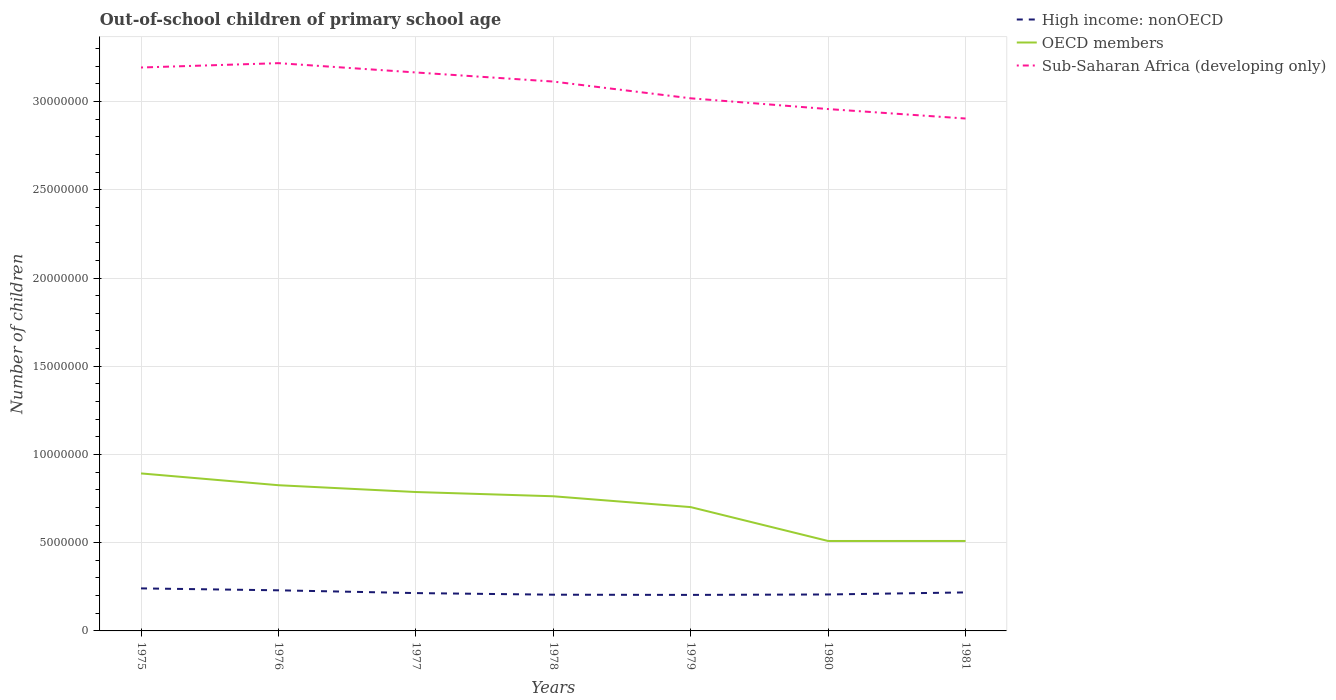Does the line corresponding to Sub-Saharan Africa (developing only) intersect with the line corresponding to OECD members?
Offer a terse response. No. Is the number of lines equal to the number of legend labels?
Your response must be concise. Yes. Across all years, what is the maximum number of out-of-school children in OECD members?
Ensure brevity in your answer.  5.10e+06. What is the total number of out-of-school children in High income: nonOECD in the graph?
Provide a short and direct response. 2.28e+05. What is the difference between the highest and the second highest number of out-of-school children in Sub-Saharan Africa (developing only)?
Keep it short and to the point. 3.14e+06. What is the difference between the highest and the lowest number of out-of-school children in Sub-Saharan Africa (developing only)?
Make the answer very short. 4. How many lines are there?
Your response must be concise. 3. How many years are there in the graph?
Give a very brief answer. 7. Are the values on the major ticks of Y-axis written in scientific E-notation?
Ensure brevity in your answer.  No. Does the graph contain any zero values?
Offer a very short reply. No. Where does the legend appear in the graph?
Ensure brevity in your answer.  Top right. How many legend labels are there?
Ensure brevity in your answer.  3. How are the legend labels stacked?
Your answer should be compact. Vertical. What is the title of the graph?
Ensure brevity in your answer.  Out-of-school children of primary school age. Does "Grenada" appear as one of the legend labels in the graph?
Your answer should be very brief. No. What is the label or title of the Y-axis?
Ensure brevity in your answer.  Number of children. What is the Number of children in High income: nonOECD in 1975?
Provide a short and direct response. 2.41e+06. What is the Number of children of OECD members in 1975?
Offer a very short reply. 8.93e+06. What is the Number of children of Sub-Saharan Africa (developing only) in 1975?
Give a very brief answer. 3.19e+07. What is the Number of children of High income: nonOECD in 1976?
Offer a very short reply. 2.30e+06. What is the Number of children in OECD members in 1976?
Offer a very short reply. 8.26e+06. What is the Number of children of Sub-Saharan Africa (developing only) in 1976?
Ensure brevity in your answer.  3.22e+07. What is the Number of children of High income: nonOECD in 1977?
Your answer should be very brief. 2.14e+06. What is the Number of children of OECD members in 1977?
Make the answer very short. 7.87e+06. What is the Number of children in Sub-Saharan Africa (developing only) in 1977?
Give a very brief answer. 3.17e+07. What is the Number of children in High income: nonOECD in 1978?
Offer a very short reply. 2.05e+06. What is the Number of children in OECD members in 1978?
Ensure brevity in your answer.  7.63e+06. What is the Number of children of Sub-Saharan Africa (developing only) in 1978?
Make the answer very short. 3.11e+07. What is the Number of children in High income: nonOECD in 1979?
Give a very brief answer. 2.04e+06. What is the Number of children of OECD members in 1979?
Offer a terse response. 7.02e+06. What is the Number of children of Sub-Saharan Africa (developing only) in 1979?
Your answer should be compact. 3.02e+07. What is the Number of children in High income: nonOECD in 1980?
Provide a short and direct response. 2.07e+06. What is the Number of children of OECD members in 1980?
Ensure brevity in your answer.  5.10e+06. What is the Number of children in Sub-Saharan Africa (developing only) in 1980?
Offer a terse response. 2.96e+07. What is the Number of children in High income: nonOECD in 1981?
Offer a terse response. 2.18e+06. What is the Number of children of OECD members in 1981?
Provide a short and direct response. 5.10e+06. What is the Number of children in Sub-Saharan Africa (developing only) in 1981?
Your answer should be very brief. 2.90e+07. Across all years, what is the maximum Number of children in High income: nonOECD?
Offer a very short reply. 2.41e+06. Across all years, what is the maximum Number of children in OECD members?
Provide a short and direct response. 8.93e+06. Across all years, what is the maximum Number of children in Sub-Saharan Africa (developing only)?
Your answer should be very brief. 3.22e+07. Across all years, what is the minimum Number of children of High income: nonOECD?
Your answer should be very brief. 2.04e+06. Across all years, what is the minimum Number of children in OECD members?
Give a very brief answer. 5.10e+06. Across all years, what is the minimum Number of children in Sub-Saharan Africa (developing only)?
Keep it short and to the point. 2.90e+07. What is the total Number of children in High income: nonOECD in the graph?
Keep it short and to the point. 1.52e+07. What is the total Number of children of OECD members in the graph?
Your answer should be compact. 4.99e+07. What is the total Number of children in Sub-Saharan Africa (developing only) in the graph?
Provide a short and direct response. 2.16e+08. What is the difference between the Number of children of High income: nonOECD in 1975 and that in 1976?
Provide a short and direct response. 1.09e+05. What is the difference between the Number of children of OECD members in 1975 and that in 1976?
Your answer should be compact. 6.68e+05. What is the difference between the Number of children in Sub-Saharan Africa (developing only) in 1975 and that in 1976?
Provide a succinct answer. -2.46e+05. What is the difference between the Number of children in High income: nonOECD in 1975 and that in 1977?
Offer a very short reply. 2.66e+05. What is the difference between the Number of children of OECD members in 1975 and that in 1977?
Keep it short and to the point. 1.05e+06. What is the difference between the Number of children of Sub-Saharan Africa (developing only) in 1975 and that in 1977?
Your answer should be very brief. 2.81e+05. What is the difference between the Number of children in High income: nonOECD in 1975 and that in 1978?
Your response must be concise. 3.58e+05. What is the difference between the Number of children of OECD members in 1975 and that in 1978?
Ensure brevity in your answer.  1.29e+06. What is the difference between the Number of children of Sub-Saharan Africa (developing only) in 1975 and that in 1978?
Provide a succinct answer. 7.97e+05. What is the difference between the Number of children of High income: nonOECD in 1975 and that in 1979?
Provide a succinct answer. 3.69e+05. What is the difference between the Number of children in OECD members in 1975 and that in 1979?
Provide a short and direct response. 1.91e+06. What is the difference between the Number of children of Sub-Saharan Africa (developing only) in 1975 and that in 1979?
Offer a terse response. 1.75e+06. What is the difference between the Number of children of High income: nonOECD in 1975 and that in 1980?
Make the answer very short. 3.45e+05. What is the difference between the Number of children of OECD members in 1975 and that in 1980?
Make the answer very short. 3.83e+06. What is the difference between the Number of children of Sub-Saharan Africa (developing only) in 1975 and that in 1980?
Ensure brevity in your answer.  2.36e+06. What is the difference between the Number of children in High income: nonOECD in 1975 and that in 1981?
Give a very brief answer. 2.28e+05. What is the difference between the Number of children of OECD members in 1975 and that in 1981?
Offer a very short reply. 3.83e+06. What is the difference between the Number of children in Sub-Saharan Africa (developing only) in 1975 and that in 1981?
Your answer should be very brief. 2.89e+06. What is the difference between the Number of children of High income: nonOECD in 1976 and that in 1977?
Ensure brevity in your answer.  1.57e+05. What is the difference between the Number of children of OECD members in 1976 and that in 1977?
Keep it short and to the point. 3.86e+05. What is the difference between the Number of children of Sub-Saharan Africa (developing only) in 1976 and that in 1977?
Ensure brevity in your answer.  5.27e+05. What is the difference between the Number of children of High income: nonOECD in 1976 and that in 1978?
Your response must be concise. 2.49e+05. What is the difference between the Number of children of OECD members in 1976 and that in 1978?
Keep it short and to the point. 6.26e+05. What is the difference between the Number of children of Sub-Saharan Africa (developing only) in 1976 and that in 1978?
Provide a succinct answer. 1.04e+06. What is the difference between the Number of children in High income: nonOECD in 1976 and that in 1979?
Make the answer very short. 2.61e+05. What is the difference between the Number of children of OECD members in 1976 and that in 1979?
Keep it short and to the point. 1.24e+06. What is the difference between the Number of children in Sub-Saharan Africa (developing only) in 1976 and that in 1979?
Offer a very short reply. 1.99e+06. What is the difference between the Number of children of High income: nonOECD in 1976 and that in 1980?
Keep it short and to the point. 2.36e+05. What is the difference between the Number of children of OECD members in 1976 and that in 1980?
Your response must be concise. 3.16e+06. What is the difference between the Number of children in Sub-Saharan Africa (developing only) in 1976 and that in 1980?
Make the answer very short. 2.60e+06. What is the difference between the Number of children in High income: nonOECD in 1976 and that in 1981?
Ensure brevity in your answer.  1.19e+05. What is the difference between the Number of children in OECD members in 1976 and that in 1981?
Keep it short and to the point. 3.16e+06. What is the difference between the Number of children of Sub-Saharan Africa (developing only) in 1976 and that in 1981?
Give a very brief answer. 3.14e+06. What is the difference between the Number of children of High income: nonOECD in 1977 and that in 1978?
Your response must be concise. 9.15e+04. What is the difference between the Number of children in OECD members in 1977 and that in 1978?
Your response must be concise. 2.41e+05. What is the difference between the Number of children in Sub-Saharan Africa (developing only) in 1977 and that in 1978?
Your response must be concise. 5.15e+05. What is the difference between the Number of children of High income: nonOECD in 1977 and that in 1979?
Give a very brief answer. 1.03e+05. What is the difference between the Number of children of OECD members in 1977 and that in 1979?
Ensure brevity in your answer.  8.55e+05. What is the difference between the Number of children in Sub-Saharan Africa (developing only) in 1977 and that in 1979?
Provide a succinct answer. 1.46e+06. What is the difference between the Number of children of High income: nonOECD in 1977 and that in 1980?
Your response must be concise. 7.85e+04. What is the difference between the Number of children of OECD members in 1977 and that in 1980?
Offer a terse response. 2.78e+06. What is the difference between the Number of children in Sub-Saharan Africa (developing only) in 1977 and that in 1980?
Make the answer very short. 2.07e+06. What is the difference between the Number of children in High income: nonOECD in 1977 and that in 1981?
Your answer should be compact. -3.80e+04. What is the difference between the Number of children in OECD members in 1977 and that in 1981?
Offer a very short reply. 2.77e+06. What is the difference between the Number of children in Sub-Saharan Africa (developing only) in 1977 and that in 1981?
Provide a succinct answer. 2.61e+06. What is the difference between the Number of children in High income: nonOECD in 1978 and that in 1979?
Ensure brevity in your answer.  1.17e+04. What is the difference between the Number of children in OECD members in 1978 and that in 1979?
Ensure brevity in your answer.  6.15e+05. What is the difference between the Number of children in Sub-Saharan Africa (developing only) in 1978 and that in 1979?
Ensure brevity in your answer.  9.50e+05. What is the difference between the Number of children of High income: nonOECD in 1978 and that in 1980?
Provide a succinct answer. -1.30e+04. What is the difference between the Number of children in OECD members in 1978 and that in 1980?
Your response must be concise. 2.53e+06. What is the difference between the Number of children in Sub-Saharan Africa (developing only) in 1978 and that in 1980?
Keep it short and to the point. 1.56e+06. What is the difference between the Number of children of High income: nonOECD in 1978 and that in 1981?
Keep it short and to the point. -1.30e+05. What is the difference between the Number of children in OECD members in 1978 and that in 1981?
Offer a terse response. 2.53e+06. What is the difference between the Number of children in Sub-Saharan Africa (developing only) in 1978 and that in 1981?
Your answer should be compact. 2.10e+06. What is the difference between the Number of children of High income: nonOECD in 1979 and that in 1980?
Your answer should be compact. -2.47e+04. What is the difference between the Number of children of OECD members in 1979 and that in 1980?
Make the answer very short. 1.92e+06. What is the difference between the Number of children of Sub-Saharan Africa (developing only) in 1979 and that in 1980?
Provide a succinct answer. 6.09e+05. What is the difference between the Number of children in High income: nonOECD in 1979 and that in 1981?
Offer a very short reply. -1.41e+05. What is the difference between the Number of children of OECD members in 1979 and that in 1981?
Your response must be concise. 1.92e+06. What is the difference between the Number of children in Sub-Saharan Africa (developing only) in 1979 and that in 1981?
Offer a terse response. 1.15e+06. What is the difference between the Number of children in High income: nonOECD in 1980 and that in 1981?
Ensure brevity in your answer.  -1.17e+05. What is the difference between the Number of children of OECD members in 1980 and that in 1981?
Offer a very short reply. -943. What is the difference between the Number of children of Sub-Saharan Africa (developing only) in 1980 and that in 1981?
Ensure brevity in your answer.  5.36e+05. What is the difference between the Number of children of High income: nonOECD in 1975 and the Number of children of OECD members in 1976?
Keep it short and to the point. -5.85e+06. What is the difference between the Number of children in High income: nonOECD in 1975 and the Number of children in Sub-Saharan Africa (developing only) in 1976?
Give a very brief answer. -2.98e+07. What is the difference between the Number of children in OECD members in 1975 and the Number of children in Sub-Saharan Africa (developing only) in 1976?
Your answer should be very brief. -2.33e+07. What is the difference between the Number of children in High income: nonOECD in 1975 and the Number of children in OECD members in 1977?
Your answer should be very brief. -5.46e+06. What is the difference between the Number of children of High income: nonOECD in 1975 and the Number of children of Sub-Saharan Africa (developing only) in 1977?
Provide a short and direct response. -2.92e+07. What is the difference between the Number of children of OECD members in 1975 and the Number of children of Sub-Saharan Africa (developing only) in 1977?
Offer a terse response. -2.27e+07. What is the difference between the Number of children in High income: nonOECD in 1975 and the Number of children in OECD members in 1978?
Provide a succinct answer. -5.22e+06. What is the difference between the Number of children in High income: nonOECD in 1975 and the Number of children in Sub-Saharan Africa (developing only) in 1978?
Offer a very short reply. -2.87e+07. What is the difference between the Number of children of OECD members in 1975 and the Number of children of Sub-Saharan Africa (developing only) in 1978?
Make the answer very short. -2.22e+07. What is the difference between the Number of children of High income: nonOECD in 1975 and the Number of children of OECD members in 1979?
Your answer should be very brief. -4.61e+06. What is the difference between the Number of children of High income: nonOECD in 1975 and the Number of children of Sub-Saharan Africa (developing only) in 1979?
Your response must be concise. -2.78e+07. What is the difference between the Number of children in OECD members in 1975 and the Number of children in Sub-Saharan Africa (developing only) in 1979?
Make the answer very short. -2.13e+07. What is the difference between the Number of children in High income: nonOECD in 1975 and the Number of children in OECD members in 1980?
Keep it short and to the point. -2.69e+06. What is the difference between the Number of children in High income: nonOECD in 1975 and the Number of children in Sub-Saharan Africa (developing only) in 1980?
Ensure brevity in your answer.  -2.72e+07. What is the difference between the Number of children of OECD members in 1975 and the Number of children of Sub-Saharan Africa (developing only) in 1980?
Offer a very short reply. -2.07e+07. What is the difference between the Number of children in High income: nonOECD in 1975 and the Number of children in OECD members in 1981?
Offer a very short reply. -2.69e+06. What is the difference between the Number of children in High income: nonOECD in 1975 and the Number of children in Sub-Saharan Africa (developing only) in 1981?
Offer a very short reply. -2.66e+07. What is the difference between the Number of children in OECD members in 1975 and the Number of children in Sub-Saharan Africa (developing only) in 1981?
Ensure brevity in your answer.  -2.01e+07. What is the difference between the Number of children of High income: nonOECD in 1976 and the Number of children of OECD members in 1977?
Keep it short and to the point. -5.57e+06. What is the difference between the Number of children of High income: nonOECD in 1976 and the Number of children of Sub-Saharan Africa (developing only) in 1977?
Ensure brevity in your answer.  -2.93e+07. What is the difference between the Number of children in OECD members in 1976 and the Number of children in Sub-Saharan Africa (developing only) in 1977?
Your response must be concise. -2.34e+07. What is the difference between the Number of children of High income: nonOECD in 1976 and the Number of children of OECD members in 1978?
Your answer should be very brief. -5.33e+06. What is the difference between the Number of children of High income: nonOECD in 1976 and the Number of children of Sub-Saharan Africa (developing only) in 1978?
Ensure brevity in your answer.  -2.88e+07. What is the difference between the Number of children in OECD members in 1976 and the Number of children in Sub-Saharan Africa (developing only) in 1978?
Offer a very short reply. -2.29e+07. What is the difference between the Number of children in High income: nonOECD in 1976 and the Number of children in OECD members in 1979?
Your answer should be very brief. -4.72e+06. What is the difference between the Number of children of High income: nonOECD in 1976 and the Number of children of Sub-Saharan Africa (developing only) in 1979?
Your response must be concise. -2.79e+07. What is the difference between the Number of children in OECD members in 1976 and the Number of children in Sub-Saharan Africa (developing only) in 1979?
Offer a very short reply. -2.19e+07. What is the difference between the Number of children of High income: nonOECD in 1976 and the Number of children of OECD members in 1980?
Your answer should be very brief. -2.79e+06. What is the difference between the Number of children in High income: nonOECD in 1976 and the Number of children in Sub-Saharan Africa (developing only) in 1980?
Give a very brief answer. -2.73e+07. What is the difference between the Number of children in OECD members in 1976 and the Number of children in Sub-Saharan Africa (developing only) in 1980?
Provide a succinct answer. -2.13e+07. What is the difference between the Number of children of High income: nonOECD in 1976 and the Number of children of OECD members in 1981?
Provide a succinct answer. -2.80e+06. What is the difference between the Number of children in High income: nonOECD in 1976 and the Number of children in Sub-Saharan Africa (developing only) in 1981?
Offer a very short reply. -2.67e+07. What is the difference between the Number of children in OECD members in 1976 and the Number of children in Sub-Saharan Africa (developing only) in 1981?
Offer a terse response. -2.08e+07. What is the difference between the Number of children of High income: nonOECD in 1977 and the Number of children of OECD members in 1978?
Offer a very short reply. -5.49e+06. What is the difference between the Number of children of High income: nonOECD in 1977 and the Number of children of Sub-Saharan Africa (developing only) in 1978?
Offer a very short reply. -2.90e+07. What is the difference between the Number of children of OECD members in 1977 and the Number of children of Sub-Saharan Africa (developing only) in 1978?
Provide a succinct answer. -2.33e+07. What is the difference between the Number of children in High income: nonOECD in 1977 and the Number of children in OECD members in 1979?
Ensure brevity in your answer.  -4.87e+06. What is the difference between the Number of children in High income: nonOECD in 1977 and the Number of children in Sub-Saharan Africa (developing only) in 1979?
Offer a very short reply. -2.80e+07. What is the difference between the Number of children in OECD members in 1977 and the Number of children in Sub-Saharan Africa (developing only) in 1979?
Your response must be concise. -2.23e+07. What is the difference between the Number of children of High income: nonOECD in 1977 and the Number of children of OECD members in 1980?
Your answer should be very brief. -2.95e+06. What is the difference between the Number of children of High income: nonOECD in 1977 and the Number of children of Sub-Saharan Africa (developing only) in 1980?
Your response must be concise. -2.74e+07. What is the difference between the Number of children of OECD members in 1977 and the Number of children of Sub-Saharan Africa (developing only) in 1980?
Keep it short and to the point. -2.17e+07. What is the difference between the Number of children in High income: nonOECD in 1977 and the Number of children in OECD members in 1981?
Make the answer very short. -2.95e+06. What is the difference between the Number of children of High income: nonOECD in 1977 and the Number of children of Sub-Saharan Africa (developing only) in 1981?
Your answer should be very brief. -2.69e+07. What is the difference between the Number of children in OECD members in 1977 and the Number of children in Sub-Saharan Africa (developing only) in 1981?
Give a very brief answer. -2.12e+07. What is the difference between the Number of children in High income: nonOECD in 1978 and the Number of children in OECD members in 1979?
Ensure brevity in your answer.  -4.96e+06. What is the difference between the Number of children of High income: nonOECD in 1978 and the Number of children of Sub-Saharan Africa (developing only) in 1979?
Your response must be concise. -2.81e+07. What is the difference between the Number of children of OECD members in 1978 and the Number of children of Sub-Saharan Africa (developing only) in 1979?
Your answer should be compact. -2.26e+07. What is the difference between the Number of children of High income: nonOECD in 1978 and the Number of children of OECD members in 1980?
Ensure brevity in your answer.  -3.04e+06. What is the difference between the Number of children of High income: nonOECD in 1978 and the Number of children of Sub-Saharan Africa (developing only) in 1980?
Your answer should be compact. -2.75e+07. What is the difference between the Number of children in OECD members in 1978 and the Number of children in Sub-Saharan Africa (developing only) in 1980?
Provide a short and direct response. -2.19e+07. What is the difference between the Number of children in High income: nonOECD in 1978 and the Number of children in OECD members in 1981?
Offer a very short reply. -3.04e+06. What is the difference between the Number of children of High income: nonOECD in 1978 and the Number of children of Sub-Saharan Africa (developing only) in 1981?
Your answer should be very brief. -2.70e+07. What is the difference between the Number of children in OECD members in 1978 and the Number of children in Sub-Saharan Africa (developing only) in 1981?
Provide a succinct answer. -2.14e+07. What is the difference between the Number of children of High income: nonOECD in 1979 and the Number of children of OECD members in 1980?
Your answer should be very brief. -3.06e+06. What is the difference between the Number of children of High income: nonOECD in 1979 and the Number of children of Sub-Saharan Africa (developing only) in 1980?
Your answer should be very brief. -2.75e+07. What is the difference between the Number of children of OECD members in 1979 and the Number of children of Sub-Saharan Africa (developing only) in 1980?
Give a very brief answer. -2.26e+07. What is the difference between the Number of children in High income: nonOECD in 1979 and the Number of children in OECD members in 1981?
Provide a short and direct response. -3.06e+06. What is the difference between the Number of children in High income: nonOECD in 1979 and the Number of children in Sub-Saharan Africa (developing only) in 1981?
Ensure brevity in your answer.  -2.70e+07. What is the difference between the Number of children in OECD members in 1979 and the Number of children in Sub-Saharan Africa (developing only) in 1981?
Give a very brief answer. -2.20e+07. What is the difference between the Number of children in High income: nonOECD in 1980 and the Number of children in OECD members in 1981?
Ensure brevity in your answer.  -3.03e+06. What is the difference between the Number of children in High income: nonOECD in 1980 and the Number of children in Sub-Saharan Africa (developing only) in 1981?
Offer a very short reply. -2.70e+07. What is the difference between the Number of children of OECD members in 1980 and the Number of children of Sub-Saharan Africa (developing only) in 1981?
Give a very brief answer. -2.39e+07. What is the average Number of children of High income: nonOECD per year?
Your answer should be very brief. 2.17e+06. What is the average Number of children of OECD members per year?
Your answer should be compact. 7.13e+06. What is the average Number of children in Sub-Saharan Africa (developing only) per year?
Keep it short and to the point. 3.08e+07. In the year 1975, what is the difference between the Number of children in High income: nonOECD and Number of children in OECD members?
Keep it short and to the point. -6.52e+06. In the year 1975, what is the difference between the Number of children in High income: nonOECD and Number of children in Sub-Saharan Africa (developing only)?
Offer a very short reply. -2.95e+07. In the year 1975, what is the difference between the Number of children in OECD members and Number of children in Sub-Saharan Africa (developing only)?
Keep it short and to the point. -2.30e+07. In the year 1976, what is the difference between the Number of children of High income: nonOECD and Number of children of OECD members?
Give a very brief answer. -5.96e+06. In the year 1976, what is the difference between the Number of children in High income: nonOECD and Number of children in Sub-Saharan Africa (developing only)?
Provide a succinct answer. -2.99e+07. In the year 1976, what is the difference between the Number of children of OECD members and Number of children of Sub-Saharan Africa (developing only)?
Give a very brief answer. -2.39e+07. In the year 1977, what is the difference between the Number of children of High income: nonOECD and Number of children of OECD members?
Give a very brief answer. -5.73e+06. In the year 1977, what is the difference between the Number of children in High income: nonOECD and Number of children in Sub-Saharan Africa (developing only)?
Ensure brevity in your answer.  -2.95e+07. In the year 1977, what is the difference between the Number of children in OECD members and Number of children in Sub-Saharan Africa (developing only)?
Provide a short and direct response. -2.38e+07. In the year 1978, what is the difference between the Number of children of High income: nonOECD and Number of children of OECD members?
Make the answer very short. -5.58e+06. In the year 1978, what is the difference between the Number of children in High income: nonOECD and Number of children in Sub-Saharan Africa (developing only)?
Keep it short and to the point. -2.91e+07. In the year 1978, what is the difference between the Number of children of OECD members and Number of children of Sub-Saharan Africa (developing only)?
Provide a short and direct response. -2.35e+07. In the year 1979, what is the difference between the Number of children of High income: nonOECD and Number of children of OECD members?
Give a very brief answer. -4.98e+06. In the year 1979, what is the difference between the Number of children of High income: nonOECD and Number of children of Sub-Saharan Africa (developing only)?
Offer a terse response. -2.81e+07. In the year 1979, what is the difference between the Number of children of OECD members and Number of children of Sub-Saharan Africa (developing only)?
Provide a short and direct response. -2.32e+07. In the year 1980, what is the difference between the Number of children of High income: nonOECD and Number of children of OECD members?
Offer a very short reply. -3.03e+06. In the year 1980, what is the difference between the Number of children in High income: nonOECD and Number of children in Sub-Saharan Africa (developing only)?
Provide a succinct answer. -2.75e+07. In the year 1980, what is the difference between the Number of children in OECD members and Number of children in Sub-Saharan Africa (developing only)?
Offer a very short reply. -2.45e+07. In the year 1981, what is the difference between the Number of children in High income: nonOECD and Number of children in OECD members?
Ensure brevity in your answer.  -2.92e+06. In the year 1981, what is the difference between the Number of children in High income: nonOECD and Number of children in Sub-Saharan Africa (developing only)?
Provide a succinct answer. -2.69e+07. In the year 1981, what is the difference between the Number of children of OECD members and Number of children of Sub-Saharan Africa (developing only)?
Your response must be concise. -2.39e+07. What is the ratio of the Number of children in High income: nonOECD in 1975 to that in 1976?
Offer a very short reply. 1.05. What is the ratio of the Number of children in OECD members in 1975 to that in 1976?
Give a very brief answer. 1.08. What is the ratio of the Number of children in Sub-Saharan Africa (developing only) in 1975 to that in 1976?
Provide a short and direct response. 0.99. What is the ratio of the Number of children of High income: nonOECD in 1975 to that in 1977?
Provide a short and direct response. 1.12. What is the ratio of the Number of children of OECD members in 1975 to that in 1977?
Give a very brief answer. 1.13. What is the ratio of the Number of children in Sub-Saharan Africa (developing only) in 1975 to that in 1977?
Give a very brief answer. 1.01. What is the ratio of the Number of children of High income: nonOECD in 1975 to that in 1978?
Provide a short and direct response. 1.17. What is the ratio of the Number of children of OECD members in 1975 to that in 1978?
Your answer should be compact. 1.17. What is the ratio of the Number of children of Sub-Saharan Africa (developing only) in 1975 to that in 1978?
Provide a short and direct response. 1.03. What is the ratio of the Number of children in High income: nonOECD in 1975 to that in 1979?
Make the answer very short. 1.18. What is the ratio of the Number of children of OECD members in 1975 to that in 1979?
Ensure brevity in your answer.  1.27. What is the ratio of the Number of children in Sub-Saharan Africa (developing only) in 1975 to that in 1979?
Offer a very short reply. 1.06. What is the ratio of the Number of children in High income: nonOECD in 1975 to that in 1980?
Your answer should be compact. 1.17. What is the ratio of the Number of children in OECD members in 1975 to that in 1980?
Offer a terse response. 1.75. What is the ratio of the Number of children in Sub-Saharan Africa (developing only) in 1975 to that in 1980?
Your answer should be compact. 1.08. What is the ratio of the Number of children in High income: nonOECD in 1975 to that in 1981?
Ensure brevity in your answer.  1.1. What is the ratio of the Number of children of OECD members in 1975 to that in 1981?
Ensure brevity in your answer.  1.75. What is the ratio of the Number of children of Sub-Saharan Africa (developing only) in 1975 to that in 1981?
Offer a terse response. 1.1. What is the ratio of the Number of children of High income: nonOECD in 1976 to that in 1977?
Offer a very short reply. 1.07. What is the ratio of the Number of children of OECD members in 1976 to that in 1977?
Your answer should be compact. 1.05. What is the ratio of the Number of children of Sub-Saharan Africa (developing only) in 1976 to that in 1977?
Your response must be concise. 1.02. What is the ratio of the Number of children in High income: nonOECD in 1976 to that in 1978?
Provide a succinct answer. 1.12. What is the ratio of the Number of children of OECD members in 1976 to that in 1978?
Your answer should be compact. 1.08. What is the ratio of the Number of children of Sub-Saharan Africa (developing only) in 1976 to that in 1978?
Provide a succinct answer. 1.03. What is the ratio of the Number of children in High income: nonOECD in 1976 to that in 1979?
Provide a succinct answer. 1.13. What is the ratio of the Number of children in OECD members in 1976 to that in 1979?
Keep it short and to the point. 1.18. What is the ratio of the Number of children of Sub-Saharan Africa (developing only) in 1976 to that in 1979?
Make the answer very short. 1.07. What is the ratio of the Number of children in High income: nonOECD in 1976 to that in 1980?
Your answer should be compact. 1.11. What is the ratio of the Number of children of OECD members in 1976 to that in 1980?
Offer a very short reply. 1.62. What is the ratio of the Number of children of Sub-Saharan Africa (developing only) in 1976 to that in 1980?
Your answer should be compact. 1.09. What is the ratio of the Number of children of High income: nonOECD in 1976 to that in 1981?
Offer a very short reply. 1.05. What is the ratio of the Number of children in OECD members in 1976 to that in 1981?
Give a very brief answer. 1.62. What is the ratio of the Number of children of Sub-Saharan Africa (developing only) in 1976 to that in 1981?
Give a very brief answer. 1.11. What is the ratio of the Number of children in High income: nonOECD in 1977 to that in 1978?
Your answer should be compact. 1.04. What is the ratio of the Number of children of OECD members in 1977 to that in 1978?
Provide a short and direct response. 1.03. What is the ratio of the Number of children of Sub-Saharan Africa (developing only) in 1977 to that in 1978?
Offer a terse response. 1.02. What is the ratio of the Number of children of High income: nonOECD in 1977 to that in 1979?
Your answer should be very brief. 1.05. What is the ratio of the Number of children in OECD members in 1977 to that in 1979?
Your answer should be very brief. 1.12. What is the ratio of the Number of children in Sub-Saharan Africa (developing only) in 1977 to that in 1979?
Ensure brevity in your answer.  1.05. What is the ratio of the Number of children of High income: nonOECD in 1977 to that in 1980?
Ensure brevity in your answer.  1.04. What is the ratio of the Number of children in OECD members in 1977 to that in 1980?
Your response must be concise. 1.54. What is the ratio of the Number of children in Sub-Saharan Africa (developing only) in 1977 to that in 1980?
Offer a terse response. 1.07. What is the ratio of the Number of children of High income: nonOECD in 1977 to that in 1981?
Your response must be concise. 0.98. What is the ratio of the Number of children of OECD members in 1977 to that in 1981?
Give a very brief answer. 1.54. What is the ratio of the Number of children of Sub-Saharan Africa (developing only) in 1977 to that in 1981?
Offer a very short reply. 1.09. What is the ratio of the Number of children of High income: nonOECD in 1978 to that in 1979?
Offer a very short reply. 1.01. What is the ratio of the Number of children of OECD members in 1978 to that in 1979?
Your answer should be compact. 1.09. What is the ratio of the Number of children of Sub-Saharan Africa (developing only) in 1978 to that in 1979?
Provide a succinct answer. 1.03. What is the ratio of the Number of children in High income: nonOECD in 1978 to that in 1980?
Offer a terse response. 0.99. What is the ratio of the Number of children of OECD members in 1978 to that in 1980?
Keep it short and to the point. 1.5. What is the ratio of the Number of children of Sub-Saharan Africa (developing only) in 1978 to that in 1980?
Your answer should be compact. 1.05. What is the ratio of the Number of children of High income: nonOECD in 1978 to that in 1981?
Make the answer very short. 0.94. What is the ratio of the Number of children in OECD members in 1978 to that in 1981?
Provide a short and direct response. 1.5. What is the ratio of the Number of children of Sub-Saharan Africa (developing only) in 1978 to that in 1981?
Keep it short and to the point. 1.07. What is the ratio of the Number of children in OECD members in 1979 to that in 1980?
Make the answer very short. 1.38. What is the ratio of the Number of children in Sub-Saharan Africa (developing only) in 1979 to that in 1980?
Make the answer very short. 1.02. What is the ratio of the Number of children of High income: nonOECD in 1979 to that in 1981?
Offer a terse response. 0.94. What is the ratio of the Number of children in OECD members in 1979 to that in 1981?
Keep it short and to the point. 1.38. What is the ratio of the Number of children of Sub-Saharan Africa (developing only) in 1979 to that in 1981?
Provide a short and direct response. 1.04. What is the ratio of the Number of children of High income: nonOECD in 1980 to that in 1981?
Offer a very short reply. 0.95. What is the ratio of the Number of children of Sub-Saharan Africa (developing only) in 1980 to that in 1981?
Provide a succinct answer. 1.02. What is the difference between the highest and the second highest Number of children in High income: nonOECD?
Your answer should be very brief. 1.09e+05. What is the difference between the highest and the second highest Number of children of OECD members?
Your response must be concise. 6.68e+05. What is the difference between the highest and the second highest Number of children in Sub-Saharan Africa (developing only)?
Your answer should be compact. 2.46e+05. What is the difference between the highest and the lowest Number of children in High income: nonOECD?
Offer a terse response. 3.69e+05. What is the difference between the highest and the lowest Number of children of OECD members?
Offer a very short reply. 3.83e+06. What is the difference between the highest and the lowest Number of children in Sub-Saharan Africa (developing only)?
Offer a very short reply. 3.14e+06. 